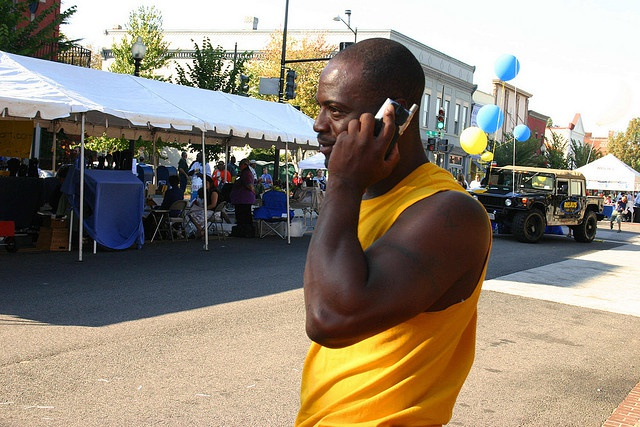Describe the objects in this image and their specific colors. I can see people in darkgreen, black, brown, maroon, and gray tones, truck in darkgreen, black, gray, tan, and khaki tones, people in darkgreen, black, gray, maroon, and navy tones, people in darkgreen, black, gray, and maroon tones, and cell phone in darkgreen, black, white, gray, and maroon tones in this image. 